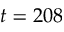Convert formula to latex. <formula><loc_0><loc_0><loc_500><loc_500>t = 2 0 8</formula> 